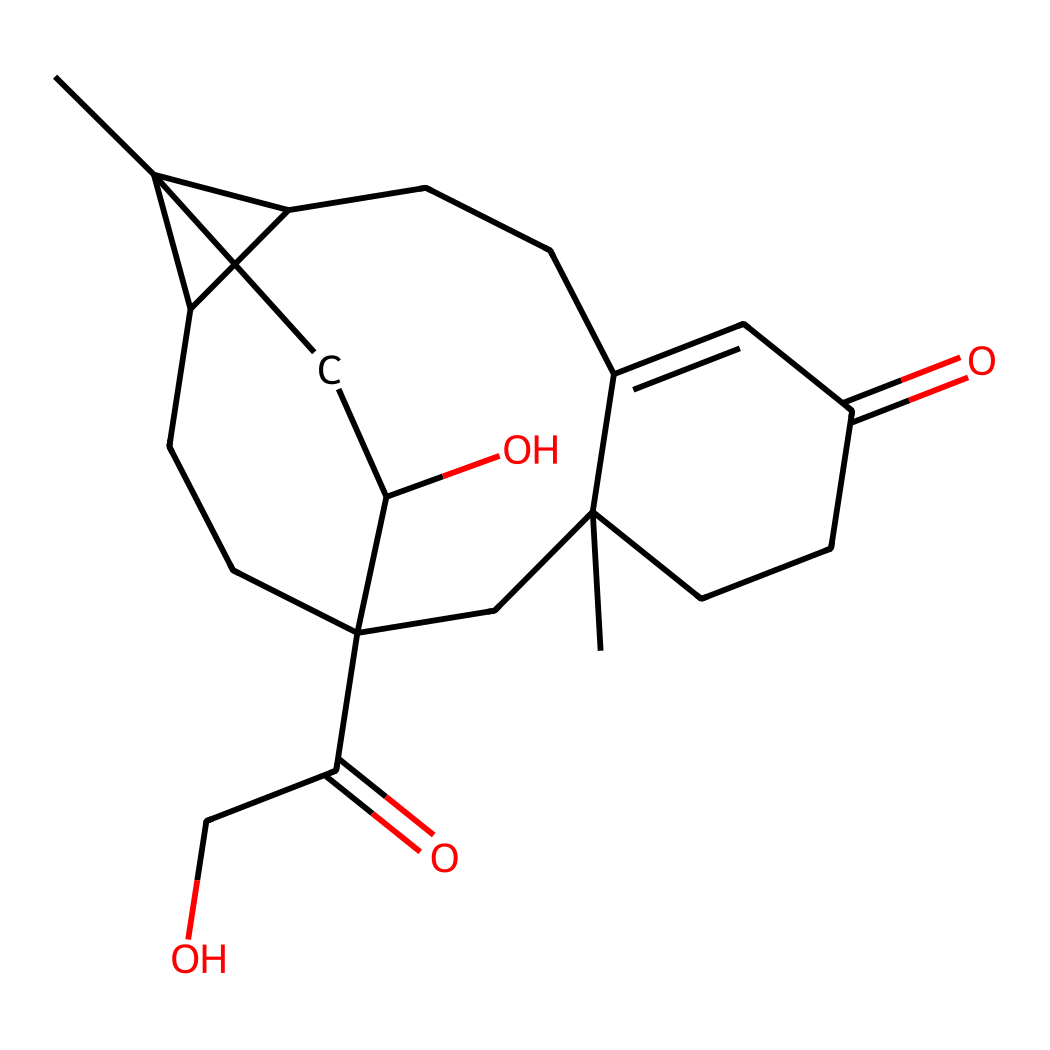What is the primary functionality of cortisol? Cortisol is a steroid hormone, mainly categorized as a glucocorticoid due to its role in glucose metabolism and the response to stress.
Answer: steroid hormone How many carbon atoms are present in the cortisol structure? By counting the carbon atoms in the provided SMILES, we find there are 21 carbon atoms in total.
Answer: 21 What type of chemical structure does cortisol feature predominantly? Cortisol contains multiple interconnected rings, characteristic of steroid structures often described as polycyclic.
Answer: polycyclic What two functional groups are prominent in cortisol? The chemical structure contains hydroxyl (-OH) groups indicating alcohol functionalities, and keto (=O) groups indicating it has carbonyl functionalities.
Answer: alcohol and carbonyl How many rings are present in the cortisol structure? The structure can be analyzed to observe there are four interconnected cyclohexane rings, characteristic of steroid hormones.
Answer: four In what way does cortisol relate to stress response? Cortisol's primary function in the body involves regulation of stress responses, particularly in the process of mobilizing energy during stress periods.
Answer: regulation of stress responses 